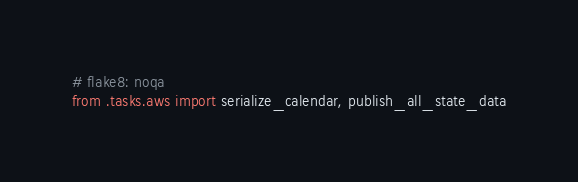<code> <loc_0><loc_0><loc_500><loc_500><_Python_># flake8: noqa
from .tasks.aws import serialize_calendar, publish_all_state_data</code> 